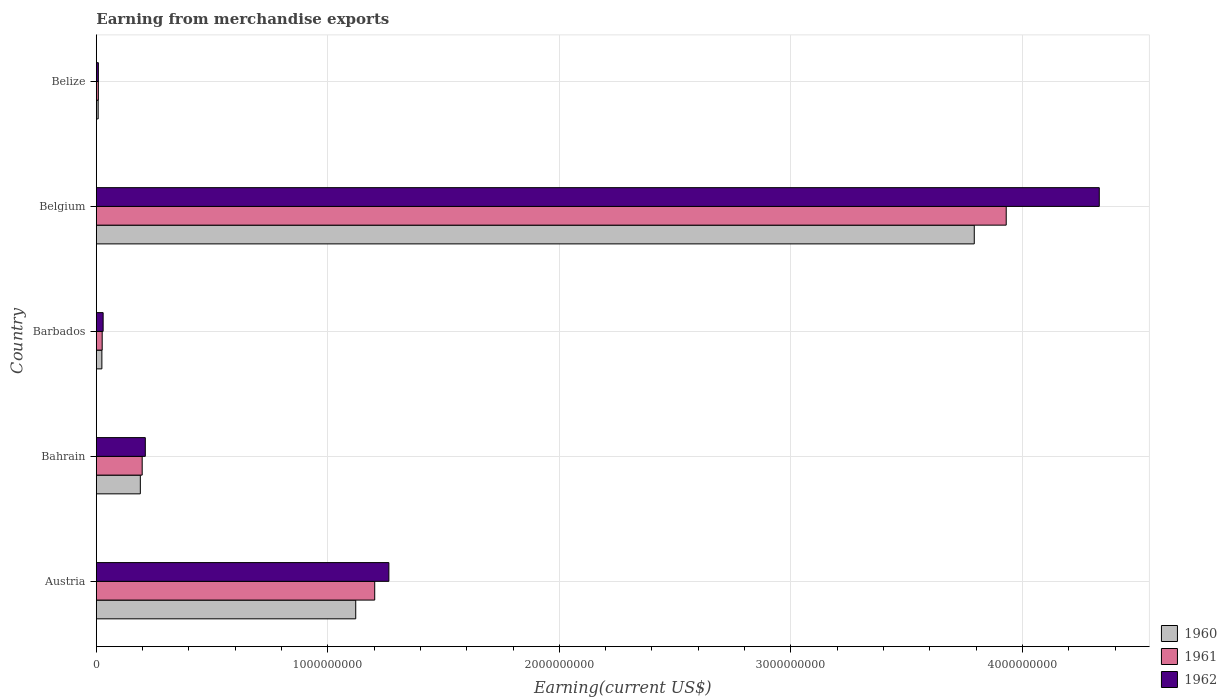How many groups of bars are there?
Ensure brevity in your answer.  5. Are the number of bars per tick equal to the number of legend labels?
Provide a short and direct response. Yes. Are the number of bars on each tick of the Y-axis equal?
Ensure brevity in your answer.  Yes. How many bars are there on the 2nd tick from the bottom?
Your answer should be compact. 3. What is the label of the 4th group of bars from the top?
Your response must be concise. Bahrain. What is the amount earned from merchandise exports in 1962 in Austria?
Offer a terse response. 1.26e+09. Across all countries, what is the maximum amount earned from merchandise exports in 1960?
Make the answer very short. 3.79e+09. Across all countries, what is the minimum amount earned from merchandise exports in 1962?
Your answer should be very brief. 8.67e+06. In which country was the amount earned from merchandise exports in 1960 maximum?
Your answer should be very brief. Belgium. In which country was the amount earned from merchandise exports in 1961 minimum?
Keep it short and to the point. Belize. What is the total amount earned from merchandise exports in 1962 in the graph?
Give a very brief answer. 5.84e+09. What is the difference between the amount earned from merchandise exports in 1960 in Barbados and that in Belize?
Keep it short and to the point. 1.60e+07. What is the difference between the amount earned from merchandise exports in 1960 in Belize and the amount earned from merchandise exports in 1962 in Austria?
Provide a short and direct response. -1.26e+09. What is the average amount earned from merchandise exports in 1961 per country?
Offer a terse response. 1.07e+09. What is the difference between the amount earned from merchandise exports in 1960 and amount earned from merchandise exports in 1961 in Bahrain?
Give a very brief answer. -8.00e+06. In how many countries, is the amount earned from merchandise exports in 1960 greater than 800000000 US$?
Ensure brevity in your answer.  2. What is the ratio of the amount earned from merchandise exports in 1961 in Barbados to that in Belize?
Provide a short and direct response. 2.91. Is the amount earned from merchandise exports in 1961 in Austria less than that in Belize?
Your response must be concise. No. What is the difference between the highest and the second highest amount earned from merchandise exports in 1960?
Keep it short and to the point. 2.67e+09. What is the difference between the highest and the lowest amount earned from merchandise exports in 1962?
Provide a succinct answer. 4.32e+09. Is the sum of the amount earned from merchandise exports in 1960 in Bahrain and Barbados greater than the maximum amount earned from merchandise exports in 1961 across all countries?
Ensure brevity in your answer.  No. What does the 2nd bar from the bottom in Barbados represents?
Make the answer very short. 1961. How many bars are there?
Provide a succinct answer. 15. Are all the bars in the graph horizontal?
Give a very brief answer. Yes. How many countries are there in the graph?
Your answer should be very brief. 5. Are the values on the major ticks of X-axis written in scientific E-notation?
Offer a very short reply. No. Does the graph contain any zero values?
Offer a terse response. No. How many legend labels are there?
Ensure brevity in your answer.  3. How are the legend labels stacked?
Provide a short and direct response. Vertical. What is the title of the graph?
Your answer should be very brief. Earning from merchandise exports. What is the label or title of the X-axis?
Your answer should be compact. Earning(current US$). What is the Earning(current US$) of 1960 in Austria?
Offer a very short reply. 1.12e+09. What is the Earning(current US$) in 1961 in Austria?
Offer a terse response. 1.20e+09. What is the Earning(current US$) in 1962 in Austria?
Ensure brevity in your answer.  1.26e+09. What is the Earning(current US$) in 1960 in Bahrain?
Offer a terse response. 1.90e+08. What is the Earning(current US$) of 1961 in Bahrain?
Your response must be concise. 1.98e+08. What is the Earning(current US$) in 1962 in Bahrain?
Give a very brief answer. 2.12e+08. What is the Earning(current US$) of 1960 in Barbados?
Give a very brief answer. 2.39e+07. What is the Earning(current US$) in 1961 in Barbados?
Your answer should be very brief. 2.52e+07. What is the Earning(current US$) in 1962 in Barbados?
Offer a terse response. 2.93e+07. What is the Earning(current US$) in 1960 in Belgium?
Provide a short and direct response. 3.79e+09. What is the Earning(current US$) in 1961 in Belgium?
Provide a short and direct response. 3.93e+09. What is the Earning(current US$) in 1962 in Belgium?
Your answer should be compact. 4.33e+09. What is the Earning(current US$) in 1960 in Belize?
Make the answer very short. 7.87e+06. What is the Earning(current US$) in 1961 in Belize?
Provide a succinct answer. 8.68e+06. What is the Earning(current US$) of 1962 in Belize?
Your answer should be very brief. 8.67e+06. Across all countries, what is the maximum Earning(current US$) of 1960?
Offer a very short reply. 3.79e+09. Across all countries, what is the maximum Earning(current US$) in 1961?
Keep it short and to the point. 3.93e+09. Across all countries, what is the maximum Earning(current US$) in 1962?
Give a very brief answer. 4.33e+09. Across all countries, what is the minimum Earning(current US$) in 1960?
Your answer should be very brief. 7.87e+06. Across all countries, what is the minimum Earning(current US$) of 1961?
Provide a succinct answer. 8.68e+06. Across all countries, what is the minimum Earning(current US$) of 1962?
Provide a short and direct response. 8.67e+06. What is the total Earning(current US$) of 1960 in the graph?
Keep it short and to the point. 5.13e+09. What is the total Earning(current US$) in 1961 in the graph?
Offer a terse response. 5.36e+09. What is the total Earning(current US$) of 1962 in the graph?
Keep it short and to the point. 5.84e+09. What is the difference between the Earning(current US$) of 1960 in Austria and that in Bahrain?
Ensure brevity in your answer.  9.30e+08. What is the difference between the Earning(current US$) of 1961 in Austria and that in Bahrain?
Your answer should be very brief. 1.00e+09. What is the difference between the Earning(current US$) of 1962 in Austria and that in Bahrain?
Provide a short and direct response. 1.05e+09. What is the difference between the Earning(current US$) of 1960 in Austria and that in Barbados?
Ensure brevity in your answer.  1.10e+09. What is the difference between the Earning(current US$) of 1961 in Austria and that in Barbados?
Make the answer very short. 1.18e+09. What is the difference between the Earning(current US$) in 1962 in Austria and that in Barbados?
Your answer should be very brief. 1.23e+09. What is the difference between the Earning(current US$) of 1960 in Austria and that in Belgium?
Your answer should be compact. -2.67e+09. What is the difference between the Earning(current US$) in 1961 in Austria and that in Belgium?
Your answer should be very brief. -2.73e+09. What is the difference between the Earning(current US$) of 1962 in Austria and that in Belgium?
Give a very brief answer. -3.07e+09. What is the difference between the Earning(current US$) in 1960 in Austria and that in Belize?
Give a very brief answer. 1.11e+09. What is the difference between the Earning(current US$) in 1961 in Austria and that in Belize?
Give a very brief answer. 1.19e+09. What is the difference between the Earning(current US$) of 1962 in Austria and that in Belize?
Offer a very short reply. 1.25e+09. What is the difference between the Earning(current US$) of 1960 in Bahrain and that in Barbados?
Your answer should be compact. 1.66e+08. What is the difference between the Earning(current US$) in 1961 in Bahrain and that in Barbados?
Your answer should be compact. 1.73e+08. What is the difference between the Earning(current US$) of 1962 in Bahrain and that in Barbados?
Your answer should be compact. 1.82e+08. What is the difference between the Earning(current US$) in 1960 in Bahrain and that in Belgium?
Your response must be concise. -3.60e+09. What is the difference between the Earning(current US$) of 1961 in Bahrain and that in Belgium?
Your response must be concise. -3.73e+09. What is the difference between the Earning(current US$) of 1962 in Bahrain and that in Belgium?
Keep it short and to the point. -4.12e+09. What is the difference between the Earning(current US$) of 1960 in Bahrain and that in Belize?
Offer a terse response. 1.82e+08. What is the difference between the Earning(current US$) in 1961 in Bahrain and that in Belize?
Offer a terse response. 1.89e+08. What is the difference between the Earning(current US$) in 1962 in Bahrain and that in Belize?
Make the answer very short. 2.03e+08. What is the difference between the Earning(current US$) in 1960 in Barbados and that in Belgium?
Your answer should be compact. -3.77e+09. What is the difference between the Earning(current US$) in 1961 in Barbados and that in Belgium?
Keep it short and to the point. -3.90e+09. What is the difference between the Earning(current US$) of 1962 in Barbados and that in Belgium?
Offer a very short reply. -4.30e+09. What is the difference between the Earning(current US$) of 1960 in Barbados and that in Belize?
Offer a very short reply. 1.60e+07. What is the difference between the Earning(current US$) in 1961 in Barbados and that in Belize?
Offer a very short reply. 1.65e+07. What is the difference between the Earning(current US$) of 1962 in Barbados and that in Belize?
Offer a very short reply. 2.07e+07. What is the difference between the Earning(current US$) of 1960 in Belgium and that in Belize?
Make the answer very short. 3.78e+09. What is the difference between the Earning(current US$) in 1961 in Belgium and that in Belize?
Your answer should be very brief. 3.92e+09. What is the difference between the Earning(current US$) in 1962 in Belgium and that in Belize?
Offer a very short reply. 4.32e+09. What is the difference between the Earning(current US$) in 1960 in Austria and the Earning(current US$) in 1961 in Bahrain?
Provide a short and direct response. 9.22e+08. What is the difference between the Earning(current US$) of 1960 in Austria and the Earning(current US$) of 1962 in Bahrain?
Keep it short and to the point. 9.09e+08. What is the difference between the Earning(current US$) in 1961 in Austria and the Earning(current US$) in 1962 in Bahrain?
Your answer should be compact. 9.91e+08. What is the difference between the Earning(current US$) in 1960 in Austria and the Earning(current US$) in 1961 in Barbados?
Your answer should be very brief. 1.10e+09. What is the difference between the Earning(current US$) in 1960 in Austria and the Earning(current US$) in 1962 in Barbados?
Your answer should be very brief. 1.09e+09. What is the difference between the Earning(current US$) of 1961 in Austria and the Earning(current US$) of 1962 in Barbados?
Ensure brevity in your answer.  1.17e+09. What is the difference between the Earning(current US$) of 1960 in Austria and the Earning(current US$) of 1961 in Belgium?
Your answer should be compact. -2.81e+09. What is the difference between the Earning(current US$) in 1960 in Austria and the Earning(current US$) in 1962 in Belgium?
Ensure brevity in your answer.  -3.21e+09. What is the difference between the Earning(current US$) of 1961 in Austria and the Earning(current US$) of 1962 in Belgium?
Your response must be concise. -3.13e+09. What is the difference between the Earning(current US$) of 1960 in Austria and the Earning(current US$) of 1961 in Belize?
Ensure brevity in your answer.  1.11e+09. What is the difference between the Earning(current US$) in 1960 in Austria and the Earning(current US$) in 1962 in Belize?
Keep it short and to the point. 1.11e+09. What is the difference between the Earning(current US$) of 1961 in Austria and the Earning(current US$) of 1962 in Belize?
Provide a short and direct response. 1.19e+09. What is the difference between the Earning(current US$) in 1960 in Bahrain and the Earning(current US$) in 1961 in Barbados?
Provide a short and direct response. 1.65e+08. What is the difference between the Earning(current US$) in 1960 in Bahrain and the Earning(current US$) in 1962 in Barbados?
Make the answer very short. 1.61e+08. What is the difference between the Earning(current US$) in 1961 in Bahrain and the Earning(current US$) in 1962 in Barbados?
Provide a succinct answer. 1.69e+08. What is the difference between the Earning(current US$) of 1960 in Bahrain and the Earning(current US$) of 1961 in Belgium?
Ensure brevity in your answer.  -3.74e+09. What is the difference between the Earning(current US$) of 1960 in Bahrain and the Earning(current US$) of 1962 in Belgium?
Give a very brief answer. -4.14e+09. What is the difference between the Earning(current US$) in 1961 in Bahrain and the Earning(current US$) in 1962 in Belgium?
Give a very brief answer. -4.13e+09. What is the difference between the Earning(current US$) in 1960 in Bahrain and the Earning(current US$) in 1961 in Belize?
Keep it short and to the point. 1.81e+08. What is the difference between the Earning(current US$) of 1960 in Bahrain and the Earning(current US$) of 1962 in Belize?
Ensure brevity in your answer.  1.81e+08. What is the difference between the Earning(current US$) in 1961 in Bahrain and the Earning(current US$) in 1962 in Belize?
Provide a succinct answer. 1.89e+08. What is the difference between the Earning(current US$) of 1960 in Barbados and the Earning(current US$) of 1961 in Belgium?
Your answer should be compact. -3.91e+09. What is the difference between the Earning(current US$) of 1960 in Barbados and the Earning(current US$) of 1962 in Belgium?
Provide a short and direct response. -4.31e+09. What is the difference between the Earning(current US$) in 1961 in Barbados and the Earning(current US$) in 1962 in Belgium?
Offer a very short reply. -4.31e+09. What is the difference between the Earning(current US$) of 1960 in Barbados and the Earning(current US$) of 1961 in Belize?
Provide a short and direct response. 1.52e+07. What is the difference between the Earning(current US$) of 1960 in Barbados and the Earning(current US$) of 1962 in Belize?
Make the answer very short. 1.52e+07. What is the difference between the Earning(current US$) of 1961 in Barbados and the Earning(current US$) of 1962 in Belize?
Provide a succinct answer. 1.66e+07. What is the difference between the Earning(current US$) in 1960 in Belgium and the Earning(current US$) in 1961 in Belize?
Offer a very short reply. 3.78e+09. What is the difference between the Earning(current US$) in 1960 in Belgium and the Earning(current US$) in 1962 in Belize?
Offer a very short reply. 3.78e+09. What is the difference between the Earning(current US$) in 1961 in Belgium and the Earning(current US$) in 1962 in Belize?
Offer a terse response. 3.92e+09. What is the average Earning(current US$) of 1960 per country?
Provide a short and direct response. 1.03e+09. What is the average Earning(current US$) in 1961 per country?
Your answer should be very brief. 1.07e+09. What is the average Earning(current US$) of 1962 per country?
Provide a short and direct response. 1.17e+09. What is the difference between the Earning(current US$) of 1960 and Earning(current US$) of 1961 in Austria?
Your answer should be very brief. -8.20e+07. What is the difference between the Earning(current US$) in 1960 and Earning(current US$) in 1962 in Austria?
Provide a short and direct response. -1.43e+08. What is the difference between the Earning(current US$) of 1961 and Earning(current US$) of 1962 in Austria?
Provide a short and direct response. -6.11e+07. What is the difference between the Earning(current US$) of 1960 and Earning(current US$) of 1961 in Bahrain?
Offer a terse response. -8.00e+06. What is the difference between the Earning(current US$) of 1960 and Earning(current US$) of 1962 in Bahrain?
Offer a terse response. -2.15e+07. What is the difference between the Earning(current US$) in 1961 and Earning(current US$) in 1962 in Bahrain?
Your answer should be very brief. -1.35e+07. What is the difference between the Earning(current US$) of 1960 and Earning(current US$) of 1961 in Barbados?
Keep it short and to the point. -1.37e+06. What is the difference between the Earning(current US$) in 1960 and Earning(current US$) in 1962 in Barbados?
Keep it short and to the point. -5.46e+06. What is the difference between the Earning(current US$) in 1961 and Earning(current US$) in 1962 in Barbados?
Offer a terse response. -4.10e+06. What is the difference between the Earning(current US$) in 1960 and Earning(current US$) in 1961 in Belgium?
Offer a terse response. -1.38e+08. What is the difference between the Earning(current US$) of 1960 and Earning(current US$) of 1962 in Belgium?
Your answer should be very brief. -5.40e+08. What is the difference between the Earning(current US$) in 1961 and Earning(current US$) in 1962 in Belgium?
Provide a succinct answer. -4.02e+08. What is the difference between the Earning(current US$) in 1960 and Earning(current US$) in 1961 in Belize?
Offer a very short reply. -8.10e+05. What is the difference between the Earning(current US$) of 1960 and Earning(current US$) of 1962 in Belize?
Make the answer very short. -7.95e+05. What is the difference between the Earning(current US$) of 1961 and Earning(current US$) of 1962 in Belize?
Give a very brief answer. 1.47e+04. What is the ratio of the Earning(current US$) in 1960 in Austria to that in Bahrain?
Offer a terse response. 5.9. What is the ratio of the Earning(current US$) in 1961 in Austria to that in Bahrain?
Your answer should be very brief. 6.07. What is the ratio of the Earning(current US$) of 1962 in Austria to that in Bahrain?
Offer a very short reply. 5.97. What is the ratio of the Earning(current US$) of 1960 in Austria to that in Barbados?
Your response must be concise. 46.95. What is the ratio of the Earning(current US$) in 1961 in Austria to that in Barbados?
Provide a short and direct response. 47.66. What is the ratio of the Earning(current US$) of 1962 in Austria to that in Barbados?
Give a very brief answer. 43.08. What is the ratio of the Earning(current US$) of 1960 in Austria to that in Belgium?
Give a very brief answer. 0.3. What is the ratio of the Earning(current US$) in 1961 in Austria to that in Belgium?
Give a very brief answer. 0.31. What is the ratio of the Earning(current US$) in 1962 in Austria to that in Belgium?
Keep it short and to the point. 0.29. What is the ratio of the Earning(current US$) of 1960 in Austria to that in Belize?
Offer a very short reply. 142.33. What is the ratio of the Earning(current US$) of 1961 in Austria to that in Belize?
Give a very brief answer. 138.5. What is the ratio of the Earning(current US$) of 1962 in Austria to that in Belize?
Keep it short and to the point. 145.79. What is the ratio of the Earning(current US$) in 1960 in Bahrain to that in Barbados?
Provide a short and direct response. 7.96. What is the ratio of the Earning(current US$) of 1961 in Bahrain to that in Barbados?
Make the answer very short. 7.85. What is the ratio of the Earning(current US$) of 1962 in Bahrain to that in Barbados?
Provide a short and direct response. 7.21. What is the ratio of the Earning(current US$) in 1960 in Bahrain to that in Belgium?
Your answer should be compact. 0.05. What is the ratio of the Earning(current US$) in 1961 in Bahrain to that in Belgium?
Provide a succinct answer. 0.05. What is the ratio of the Earning(current US$) in 1962 in Bahrain to that in Belgium?
Make the answer very short. 0.05. What is the ratio of the Earning(current US$) in 1960 in Bahrain to that in Belize?
Your answer should be compact. 24.14. What is the ratio of the Earning(current US$) of 1961 in Bahrain to that in Belize?
Give a very brief answer. 22.81. What is the ratio of the Earning(current US$) of 1962 in Bahrain to that in Belize?
Your response must be concise. 24.4. What is the ratio of the Earning(current US$) of 1960 in Barbados to that in Belgium?
Keep it short and to the point. 0.01. What is the ratio of the Earning(current US$) of 1961 in Barbados to that in Belgium?
Your answer should be compact. 0.01. What is the ratio of the Earning(current US$) in 1962 in Barbados to that in Belgium?
Your answer should be very brief. 0.01. What is the ratio of the Earning(current US$) in 1960 in Barbados to that in Belize?
Offer a terse response. 3.03. What is the ratio of the Earning(current US$) in 1961 in Barbados to that in Belize?
Keep it short and to the point. 2.91. What is the ratio of the Earning(current US$) in 1962 in Barbados to that in Belize?
Keep it short and to the point. 3.38. What is the ratio of the Earning(current US$) of 1960 in Belgium to that in Belize?
Offer a terse response. 481.74. What is the ratio of the Earning(current US$) of 1961 in Belgium to that in Belize?
Give a very brief answer. 452.69. What is the ratio of the Earning(current US$) in 1962 in Belgium to that in Belize?
Make the answer very short. 499.84. What is the difference between the highest and the second highest Earning(current US$) in 1960?
Ensure brevity in your answer.  2.67e+09. What is the difference between the highest and the second highest Earning(current US$) of 1961?
Make the answer very short. 2.73e+09. What is the difference between the highest and the second highest Earning(current US$) of 1962?
Your answer should be very brief. 3.07e+09. What is the difference between the highest and the lowest Earning(current US$) of 1960?
Offer a very short reply. 3.78e+09. What is the difference between the highest and the lowest Earning(current US$) in 1961?
Your answer should be very brief. 3.92e+09. What is the difference between the highest and the lowest Earning(current US$) in 1962?
Keep it short and to the point. 4.32e+09. 